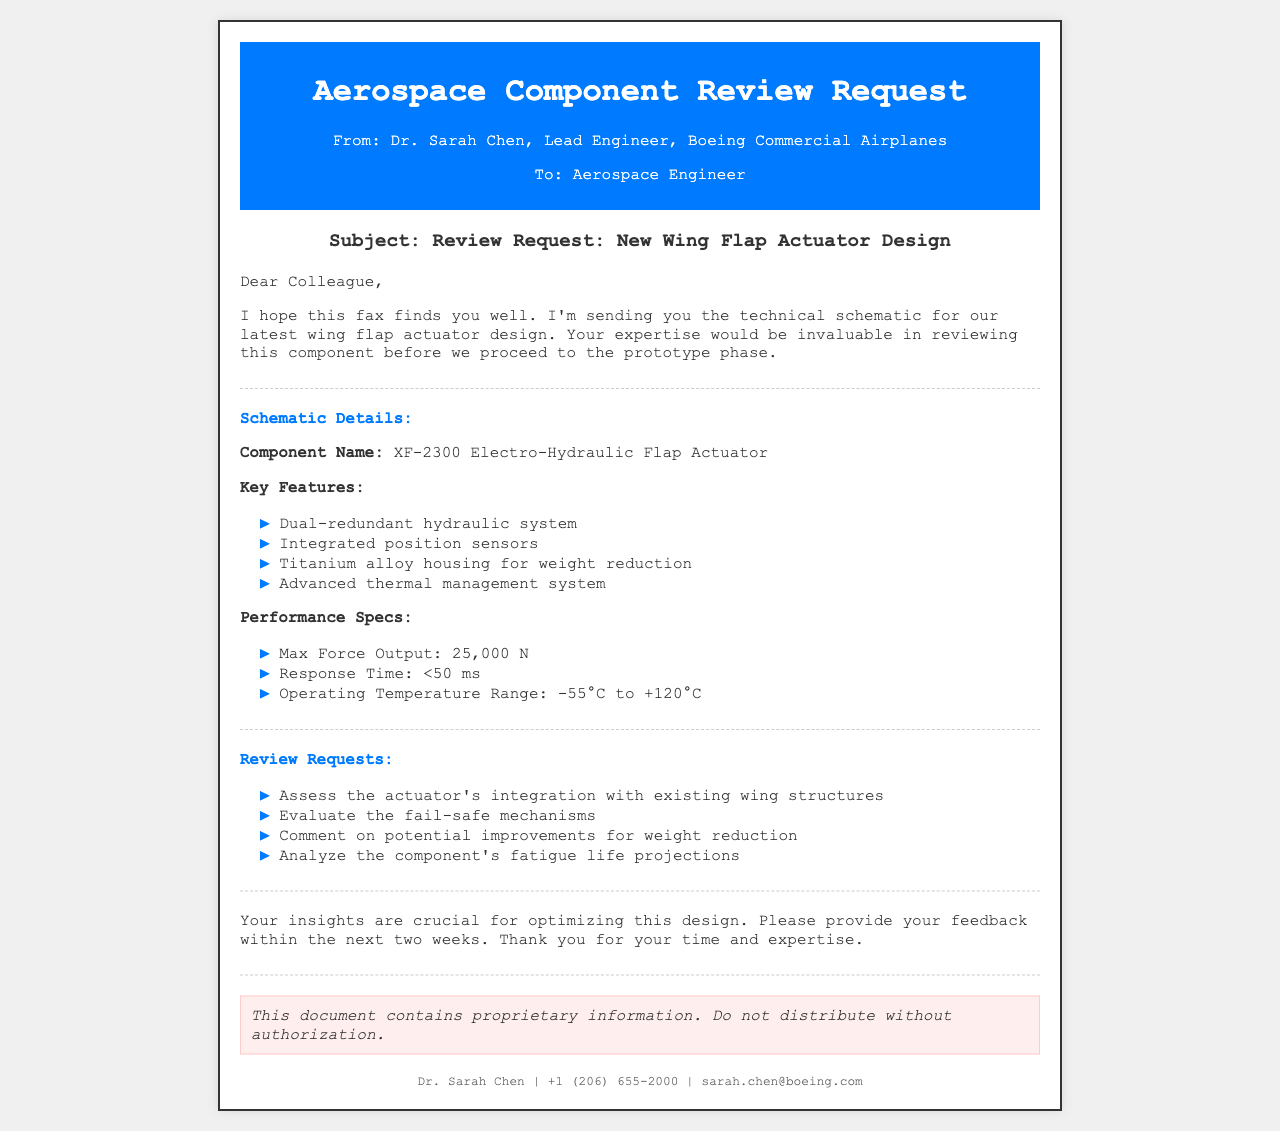What is the component name? The component name is specified in the Schematic Details section of the document.
Answer: XF-2300 Electro-Hydraulic Flap Actuator Who is the sender of the fax? The sender's information is found in the header of the document.
Answer: Dr. Sarah Chen What is the max force output of the actuator? The max force output is a specific performance specification mentioned in the document.
Answer: 25,000 N What are the key features of the actuator? The key features are listed in bullet points under Schematic Details.
Answer: Dual-redundant hydraulic system, Integrated position sensors, Titanium alloy housing for weight reduction, Advanced thermal management system What is the response time requirement? The response time is specified under the Performance Specs section in the document.
Answer: <50 ms What should be assessed regarding the actuator? The review requests include several points, assessing integration is one of them.
Answer: The actuator's integration with existing wing structures What is the operating temperature range? The operating temperature range is found in the Performance Specs section.
Answer: -55°C to +120°C What is the timeline for providing feedback? The timeline is mentioned at the end of the document.
Answer: Two weeks 